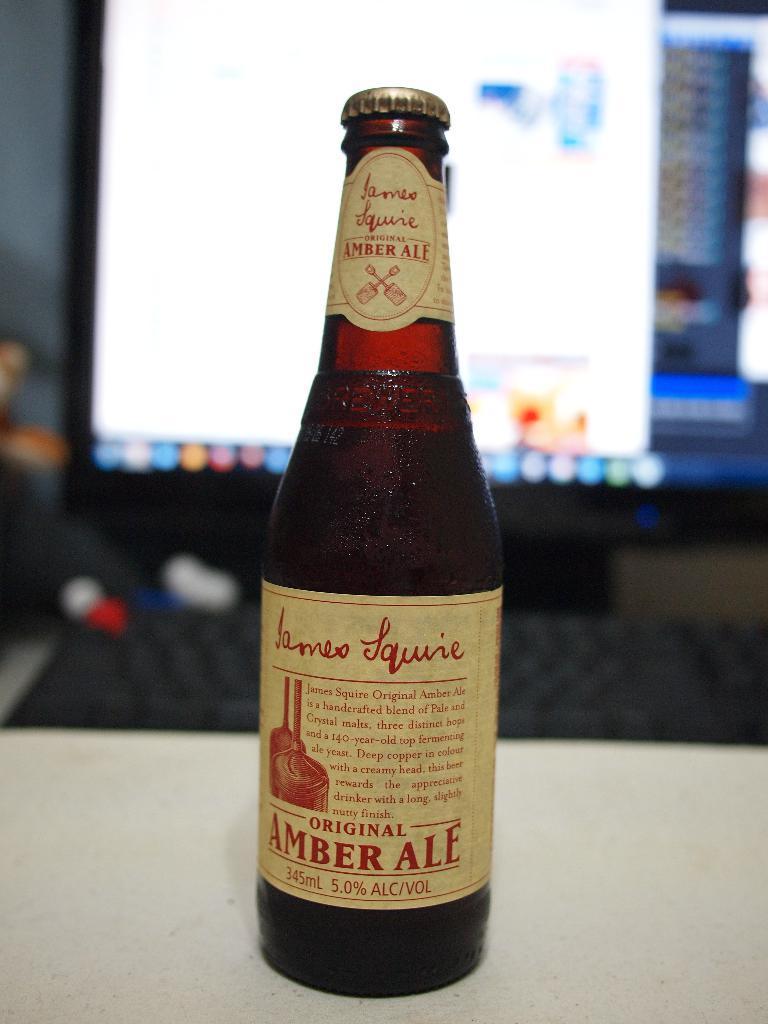In one or two sentences, can you explain what this image depicts? In the center of the image, we can see a wine bottle placed on the table and in the background, there is a screen. 